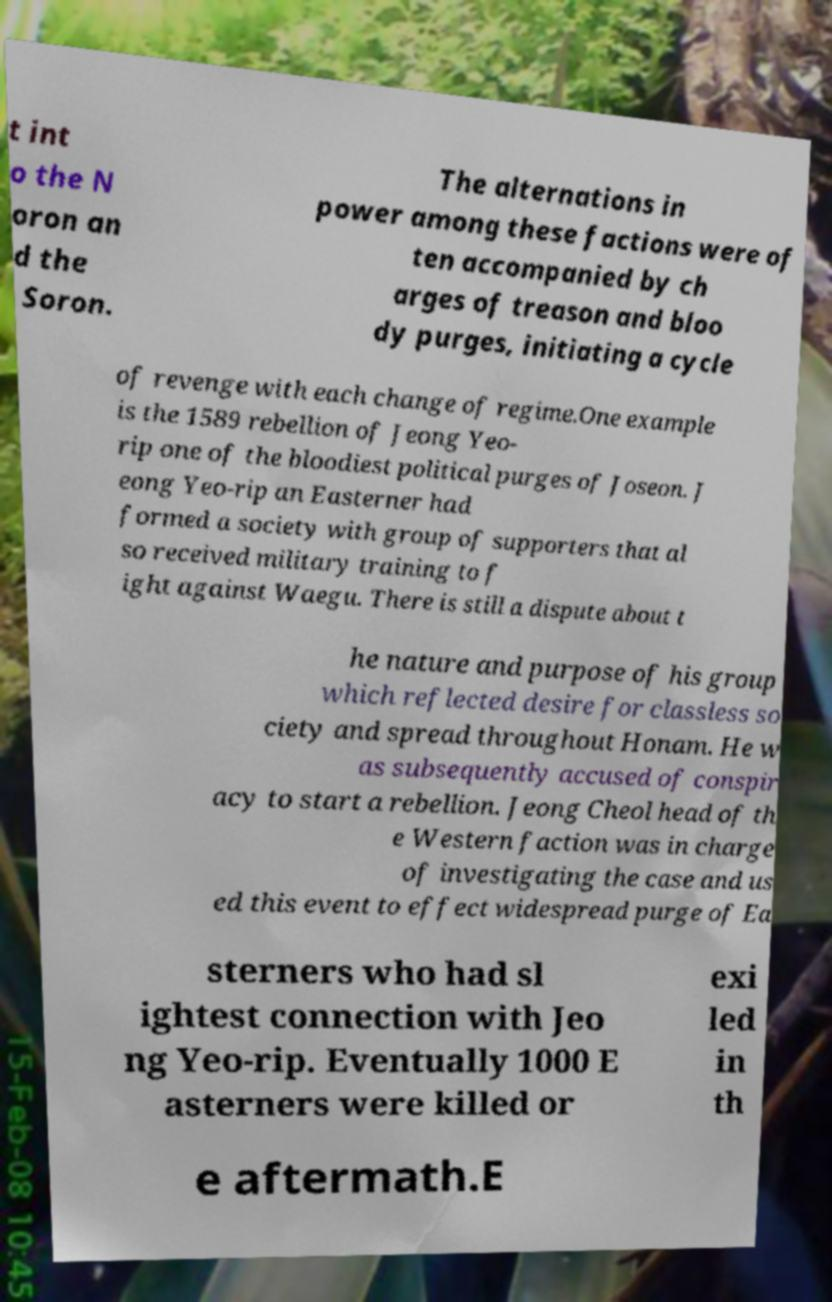Could you extract and type out the text from this image? t int o the N oron an d the Soron. The alternations in power among these factions were of ten accompanied by ch arges of treason and bloo dy purges, initiating a cycle of revenge with each change of regime.One example is the 1589 rebellion of Jeong Yeo- rip one of the bloodiest political purges of Joseon. J eong Yeo-rip an Easterner had formed a society with group of supporters that al so received military training to f ight against Waegu. There is still a dispute about t he nature and purpose of his group which reflected desire for classless so ciety and spread throughout Honam. He w as subsequently accused of conspir acy to start a rebellion. Jeong Cheol head of th e Western faction was in charge of investigating the case and us ed this event to effect widespread purge of Ea sterners who had sl ightest connection with Jeo ng Yeo-rip. Eventually 1000 E asterners were killed or exi led in th e aftermath.E 